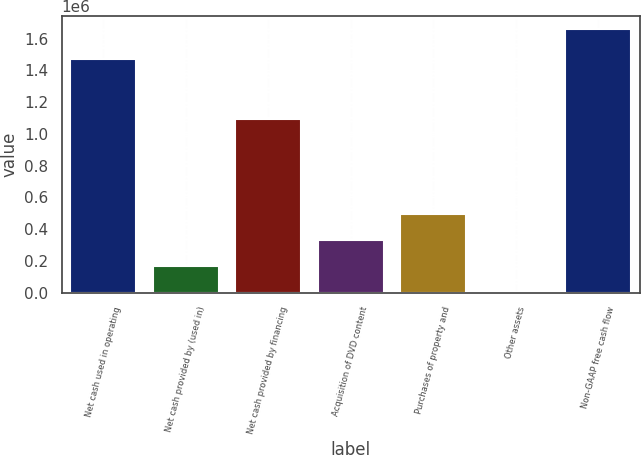<chart> <loc_0><loc_0><loc_500><loc_500><bar_chart><fcel>Net cash used in operating<fcel>Net cash provided by (used in)<fcel>Net cash provided by financing<fcel>Acquisition of DVD content<fcel>Purchases of property and<fcel>Other assets<fcel>Non-GAAP free cash flow<nl><fcel>1.47398e+06<fcel>166822<fcel>1.09163e+06<fcel>332704<fcel>498585<fcel>941<fcel>1.65976e+06<nl></chart> 